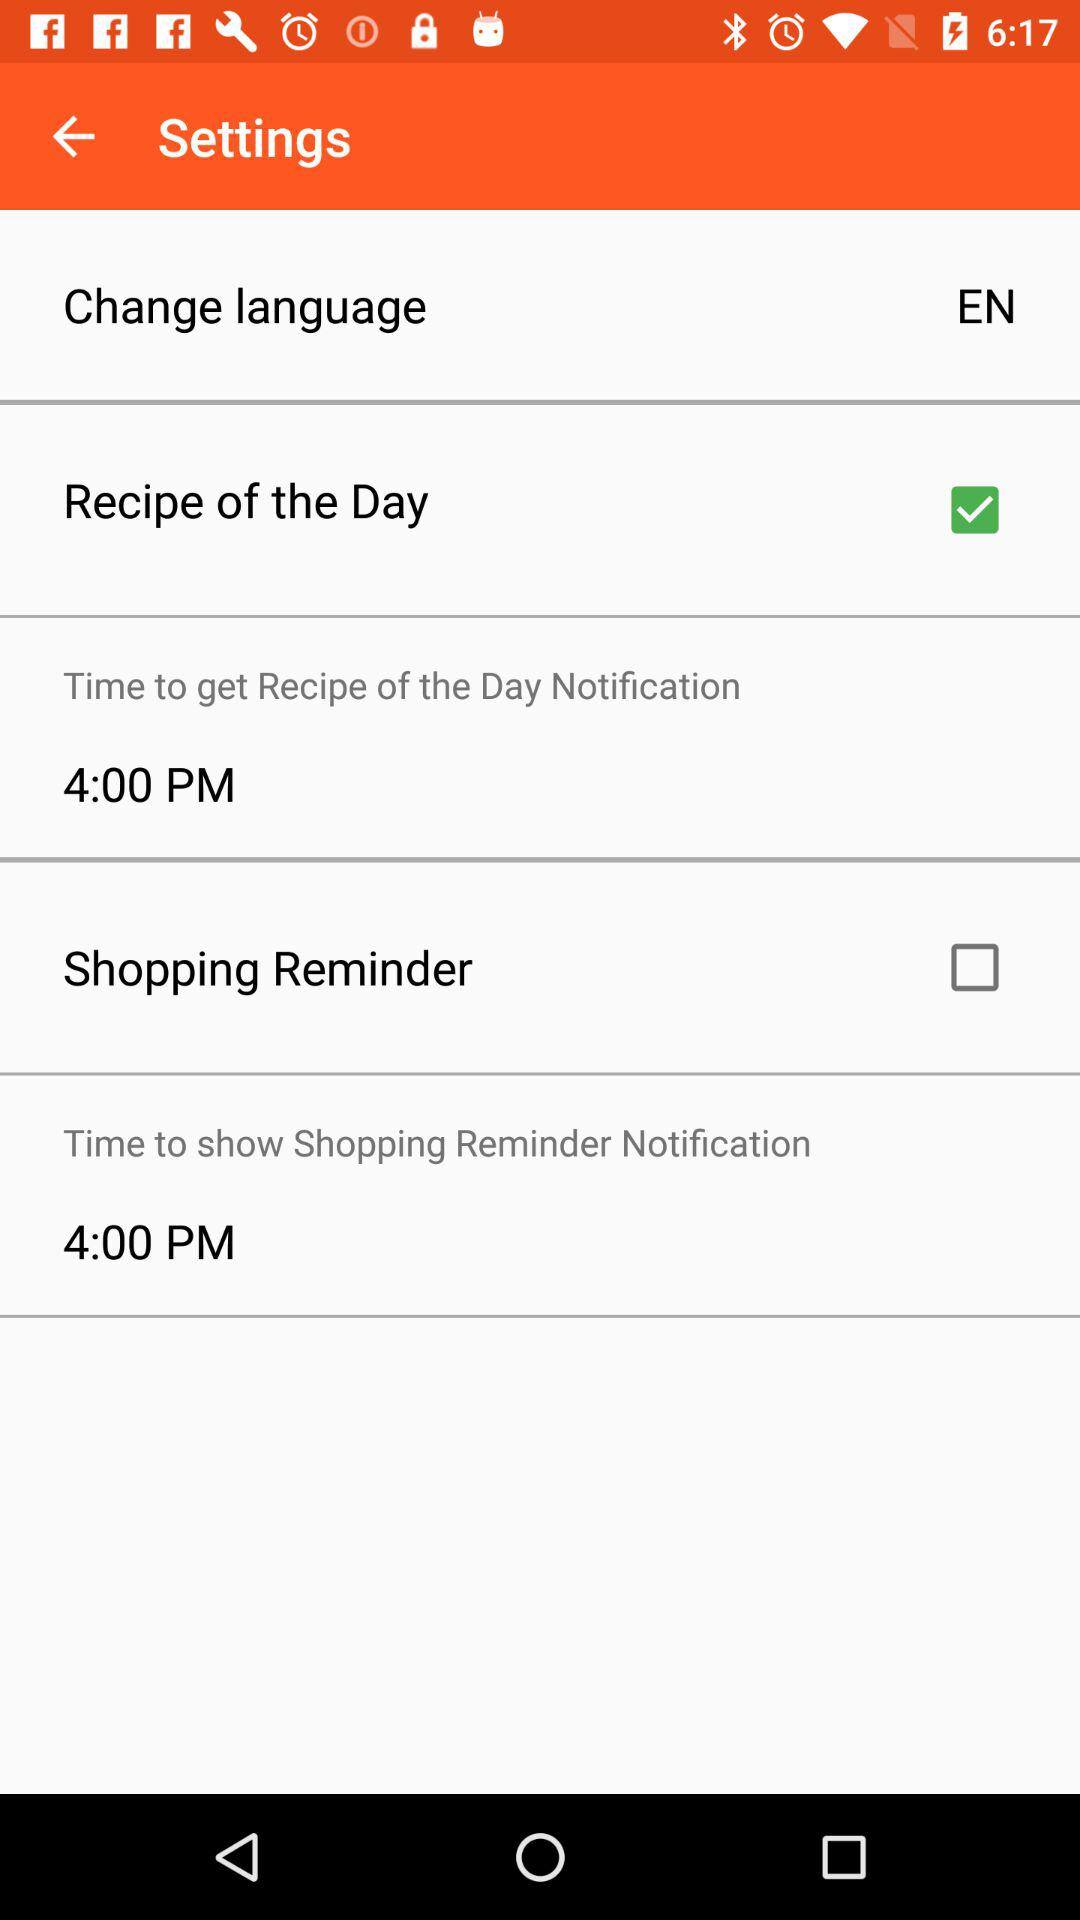What is the status of "Recipe of the Day"? The status is "on". 